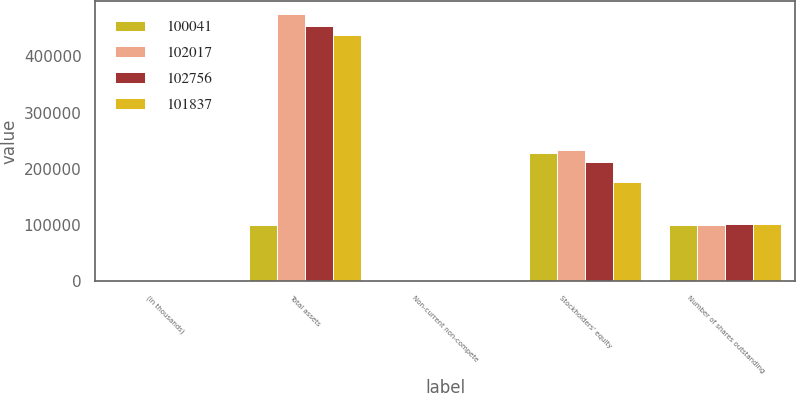Convert chart. <chart><loc_0><loc_0><loc_500><loc_500><stacked_bar_chart><ecel><fcel>(in thousands)<fcel>Total assets<fcel>Non-current non-compete<fcel>Stockholders' equity<fcel>Number of shares outstanding<nl><fcel>100041<fcel>2008<fcel>100636<fcel>2103<fcel>228433<fcel>100041<nl><fcel>102017<fcel>2007<fcel>475228<fcel>775<fcel>233553<fcel>100636<nl><fcel>102756<fcel>2006<fcel>453175<fcel>660<fcel>211459<fcel>101837<nl><fcel>101837<fcel>2005<fcel>438420<fcel>456<fcel>176951<fcel>102017<nl></chart> 